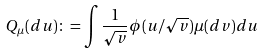<formula> <loc_0><loc_0><loc_500><loc_500>Q _ { \mu } ( d u ) \colon = \int \frac { 1 } { \sqrt { v } } \phi ( u / \sqrt { v } ) \mu ( d v ) d u</formula> 